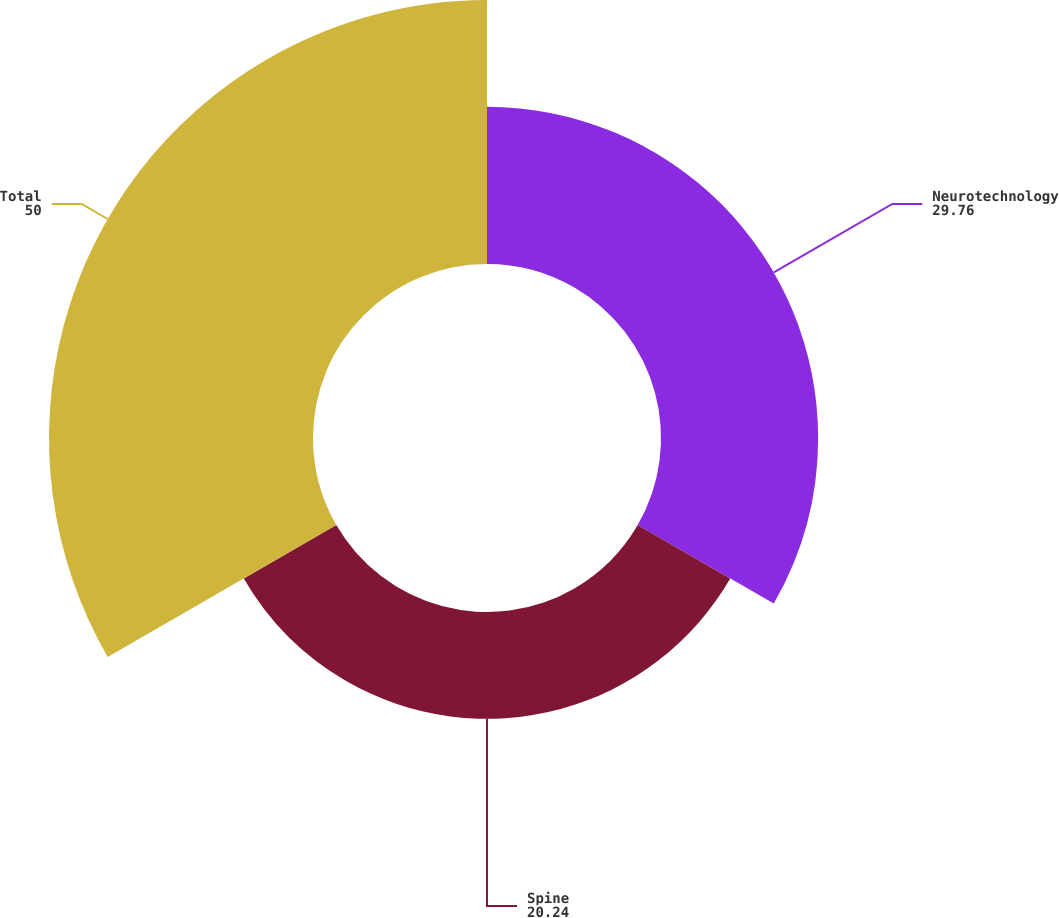Convert chart to OTSL. <chart><loc_0><loc_0><loc_500><loc_500><pie_chart><fcel>Neurotechnology<fcel>Spine<fcel>Total<nl><fcel>29.76%<fcel>20.24%<fcel>50.0%<nl></chart> 